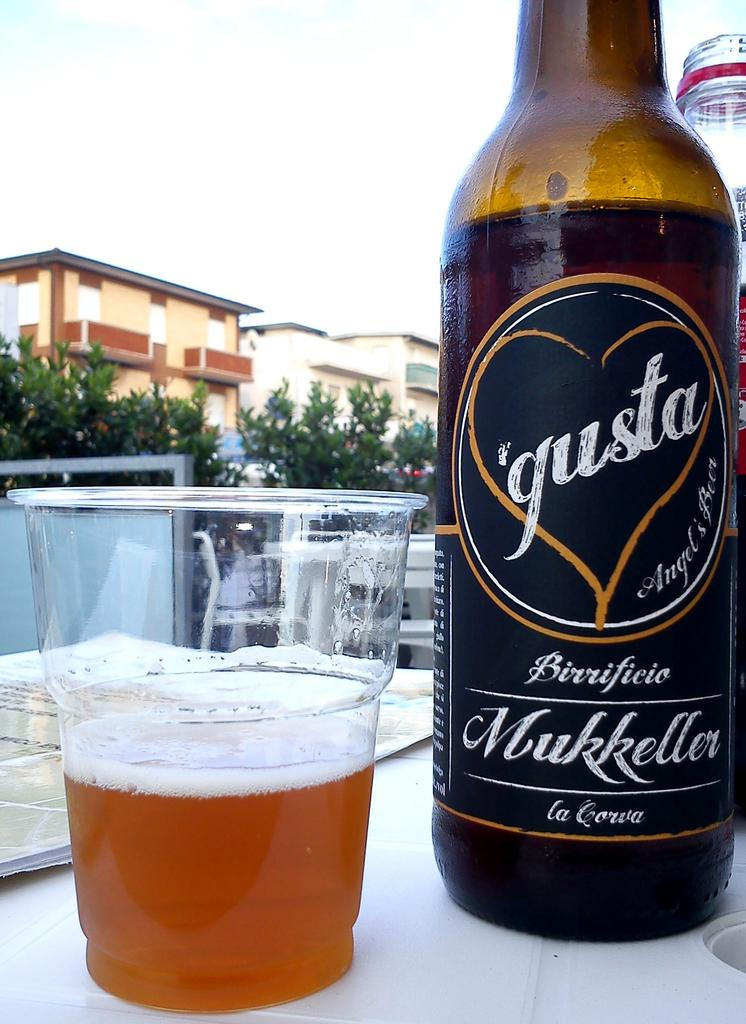Provide a one-sentence caption for the provided image. The bottle of gusta beer is next to a half full plastic cup of beer. 